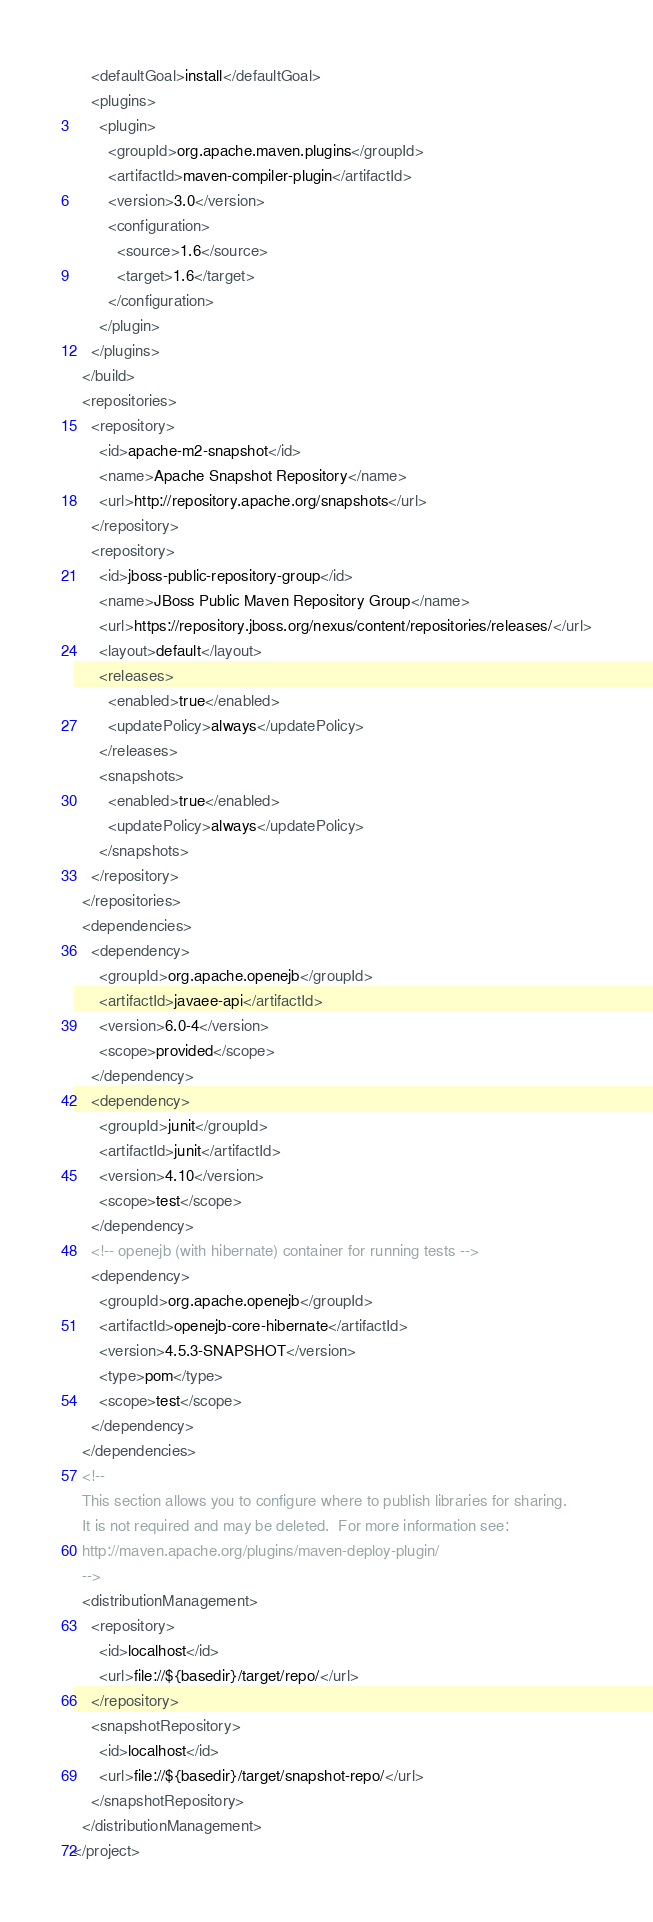Convert code to text. <code><loc_0><loc_0><loc_500><loc_500><_XML_>    <defaultGoal>install</defaultGoal>
    <plugins>
      <plugin>
        <groupId>org.apache.maven.plugins</groupId>
        <artifactId>maven-compiler-plugin</artifactId>
        <version>3.0</version>
        <configuration>
          <source>1.6</source>
          <target>1.6</target>
        </configuration>
      </plugin>
    </plugins>
  </build>
  <repositories>
    <repository>
      <id>apache-m2-snapshot</id>
      <name>Apache Snapshot Repository</name>
      <url>http://repository.apache.org/snapshots</url>
    </repository>
    <repository>
      <id>jboss-public-repository-group</id>
      <name>JBoss Public Maven Repository Group</name>
      <url>https://repository.jboss.org/nexus/content/repositories/releases/</url>
      <layout>default</layout>
      <releases>
        <enabled>true</enabled>
        <updatePolicy>always</updatePolicy>
      </releases>
      <snapshots>
        <enabled>true</enabled>
        <updatePolicy>always</updatePolicy>
      </snapshots>
    </repository>
  </repositories>
  <dependencies>
    <dependency>
      <groupId>org.apache.openejb</groupId>
      <artifactId>javaee-api</artifactId>
      <version>6.0-4</version>
      <scope>provided</scope>
    </dependency>
    <dependency>
      <groupId>junit</groupId>
      <artifactId>junit</artifactId>
      <version>4.10</version>
      <scope>test</scope>
    </dependency>
    <!-- openejb (with hibernate) container for running tests -->
    <dependency>
      <groupId>org.apache.openejb</groupId>
      <artifactId>openejb-core-hibernate</artifactId>
      <version>4.5.3-SNAPSHOT</version>
      <type>pom</type>
      <scope>test</scope>
    </dependency>
  </dependencies>
  <!--
  This section allows you to configure where to publish libraries for sharing.
  It is not required and may be deleted.  For more information see:
  http://maven.apache.org/plugins/maven-deploy-plugin/
  -->
  <distributionManagement>
    <repository>
      <id>localhost</id>
      <url>file://${basedir}/target/repo/</url>
    </repository>
    <snapshotRepository>
      <id>localhost</id>
      <url>file://${basedir}/target/snapshot-repo/</url>
    </snapshotRepository>
  </distributionManagement>
</project>
</code> 